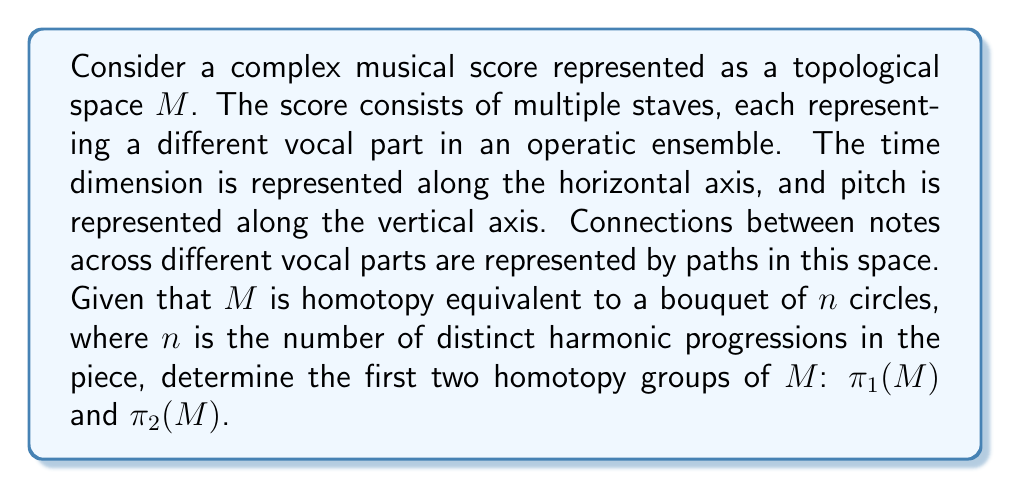Can you solve this math problem? To solve this problem, we need to understand the topological structure of the musical score and apply our knowledge of homotopy groups.

1. First, recall that a bouquet of $n$ circles, denoted as $\bigvee_{i=1}^n S^1$, is formed by taking $n$ circles and identifying a single point from each circle.

2. Given that $M$ is homotopy equivalent to a bouquet of $n$ circles, we can use the properties of homotopy equivalence to determine its homotopy groups.

3. For the first homotopy group $\pi_1(M)$:
   - The fundamental group of a bouquet of $n$ circles is isomorphic to the free group on $n$ generators: $\pi_1(\bigvee_{i=1}^n S^1) \cong F_n$
   - Since $M$ is homotopy equivalent to $\bigvee_{i=1}^n S^1$, we have: $\pi_1(M) \cong \pi_1(\bigvee_{i=1}^n S^1) \cong F_n$

4. For the second homotopy group $\pi_2(M)$:
   - Recall that for any 1-dimensional CW complex $X$, $\pi_2(X) = 0$
   - A bouquet of circles is a 1-dimensional CW complex
   - Since $M$ is homotopy equivalent to a 1-dimensional CW complex, we have: $\pi_2(M) \cong \pi_2(\bigvee_{i=1}^n S^1) = 0$

5. In the context of the musical score:
   - Each generator of the fundamental group corresponds to a distinct harmonic progression in the piece
   - The trivial second homotopy group indicates that there are no "higher-dimensional" structures in the harmonic progression space

This topological analysis provides insight into the structure of the musical piece, where the number of distinct harmonic progressions determines the complexity of the fundamental group, while the absence of higher-dimensional structures is reflected in the trivial second homotopy group.
Answer: $\pi_1(M) \cong F_n$, where $F_n$ is the free group on $n$ generators
$\pi_2(M) = 0$ 